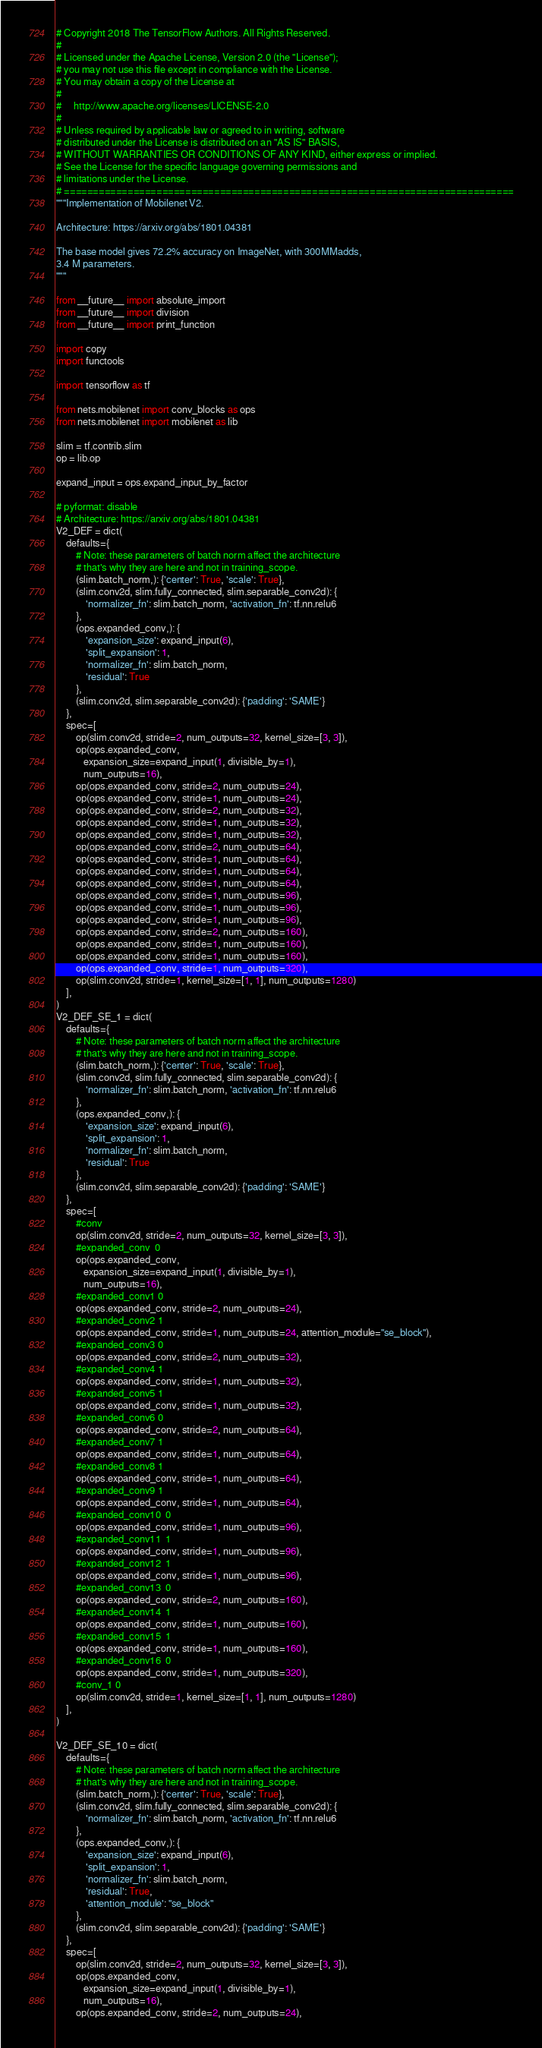<code> <loc_0><loc_0><loc_500><loc_500><_Python_># Copyright 2018 The TensorFlow Authors. All Rights Reserved.
#
# Licensed under the Apache License, Version 2.0 (the "License");
# you may not use this file except in compliance with the License.
# You may obtain a copy of the License at
#
#     http://www.apache.org/licenses/LICENSE-2.0
#
# Unless required by applicable law or agreed to in writing, software
# distributed under the License is distributed on an "AS IS" BASIS,
# WITHOUT WARRANTIES OR CONDITIONS OF ANY KIND, either express or implied.
# See the License for the specific language governing permissions and
# limitations under the License.
# ==============================================================================
"""Implementation of Mobilenet V2.

Architecture: https://arxiv.org/abs/1801.04381

The base model gives 72.2% accuracy on ImageNet, with 300MMadds,
3.4 M parameters.
"""

from __future__ import absolute_import
from __future__ import division
from __future__ import print_function

import copy
import functools

import tensorflow as tf

from nets.mobilenet import conv_blocks as ops
from nets.mobilenet import mobilenet as lib

slim = tf.contrib.slim
op = lib.op

expand_input = ops.expand_input_by_factor

# pyformat: disable
# Architecture: https://arxiv.org/abs/1801.04381
V2_DEF = dict(
    defaults={
        # Note: these parameters of batch norm affect the architecture
        # that's why they are here and not in training_scope.
        (slim.batch_norm,): {'center': True, 'scale': True},
        (slim.conv2d, slim.fully_connected, slim.separable_conv2d): {
            'normalizer_fn': slim.batch_norm, 'activation_fn': tf.nn.relu6
        },
        (ops.expanded_conv,): {
            'expansion_size': expand_input(6),
            'split_expansion': 1,
            'normalizer_fn': slim.batch_norm,
            'residual': True
        },
        (slim.conv2d, slim.separable_conv2d): {'padding': 'SAME'}
    },
    spec=[
        op(slim.conv2d, stride=2, num_outputs=32, kernel_size=[3, 3]),
        op(ops.expanded_conv,
           expansion_size=expand_input(1, divisible_by=1),
           num_outputs=16),
        op(ops.expanded_conv, stride=2, num_outputs=24),
        op(ops.expanded_conv, stride=1, num_outputs=24),
        op(ops.expanded_conv, stride=2, num_outputs=32),
        op(ops.expanded_conv, stride=1, num_outputs=32),
        op(ops.expanded_conv, stride=1, num_outputs=32),
        op(ops.expanded_conv, stride=2, num_outputs=64),
        op(ops.expanded_conv, stride=1, num_outputs=64),
        op(ops.expanded_conv, stride=1, num_outputs=64),
        op(ops.expanded_conv, stride=1, num_outputs=64),
        op(ops.expanded_conv, stride=1, num_outputs=96),
        op(ops.expanded_conv, stride=1, num_outputs=96),
        op(ops.expanded_conv, stride=1, num_outputs=96),
        op(ops.expanded_conv, stride=2, num_outputs=160),
        op(ops.expanded_conv, stride=1, num_outputs=160),
        op(ops.expanded_conv, stride=1, num_outputs=160),
        op(ops.expanded_conv, stride=1, num_outputs=320),
        op(slim.conv2d, stride=1, kernel_size=[1, 1], num_outputs=1280)
    ],
)
V2_DEF_SE_1 = dict(
    defaults={
        # Note: these parameters of batch norm affect the architecture
        # that's why they are here and not in training_scope.
        (slim.batch_norm,): {'center': True, 'scale': True},
        (slim.conv2d, slim.fully_connected, slim.separable_conv2d): {
            'normalizer_fn': slim.batch_norm, 'activation_fn': tf.nn.relu6
        },
        (ops.expanded_conv,): {
            'expansion_size': expand_input(6),
            'split_expansion': 1,
            'normalizer_fn': slim.batch_norm,
            'residual': True
        },
        (slim.conv2d, slim.separable_conv2d): {'padding': 'SAME'}
    },
    spec=[
        #conv
        op(slim.conv2d, stride=2, num_outputs=32, kernel_size=[3, 3]),
        #expanded_conv  0
        op(ops.expanded_conv,
           expansion_size=expand_input(1, divisible_by=1),
           num_outputs=16),
        #expanded_conv1 0
        op(ops.expanded_conv, stride=2, num_outputs=24),
        #expanded_conv2 1
        op(ops.expanded_conv, stride=1, num_outputs=24, attention_module="se_block"),
        #expanded_conv3 0
        op(ops.expanded_conv, stride=2, num_outputs=32),
        #expanded_conv4 1
        op(ops.expanded_conv, stride=1, num_outputs=32),
        #expanded_conv5 1
        op(ops.expanded_conv, stride=1, num_outputs=32),
        #expanded_conv6 0
        op(ops.expanded_conv, stride=2, num_outputs=64),
        #expanded_conv7 1
        op(ops.expanded_conv, stride=1, num_outputs=64),
        #expanded_conv8 1
        op(ops.expanded_conv, stride=1, num_outputs=64),
        #expanded_conv9 1
        op(ops.expanded_conv, stride=1, num_outputs=64),
        #expanded_conv10  0
        op(ops.expanded_conv, stride=1, num_outputs=96),
        #expanded_conv11  1
        op(ops.expanded_conv, stride=1, num_outputs=96),
        #expanded_conv12  1
        op(ops.expanded_conv, stride=1, num_outputs=96),
        #expanded_conv13  0
        op(ops.expanded_conv, stride=2, num_outputs=160),
        #expanded_conv14  1
        op(ops.expanded_conv, stride=1, num_outputs=160),
        #expanded_conv15  1
        op(ops.expanded_conv, stride=1, num_outputs=160),
        #expanded_conv16  0
        op(ops.expanded_conv, stride=1, num_outputs=320),
        #conv_1 0
        op(slim.conv2d, stride=1, kernel_size=[1, 1], num_outputs=1280)
    ],
)

V2_DEF_SE_10 = dict(
    defaults={
        # Note: these parameters of batch norm affect the architecture
        # that's why they are here and not in training_scope.
        (slim.batch_norm,): {'center': True, 'scale': True},
        (slim.conv2d, slim.fully_connected, slim.separable_conv2d): {
            'normalizer_fn': slim.batch_norm, 'activation_fn': tf.nn.relu6
        },
        (ops.expanded_conv,): {
            'expansion_size': expand_input(6),
            'split_expansion': 1,
            'normalizer_fn': slim.batch_norm,
            'residual': True,
            'attention_module': "se_block"
        },
        (slim.conv2d, slim.separable_conv2d): {'padding': 'SAME'}
    },
    spec=[
        op(slim.conv2d, stride=2, num_outputs=32, kernel_size=[3, 3]),
        op(ops.expanded_conv,
           expansion_size=expand_input(1, divisible_by=1),
           num_outputs=16),
        op(ops.expanded_conv, stride=2, num_outputs=24),</code> 